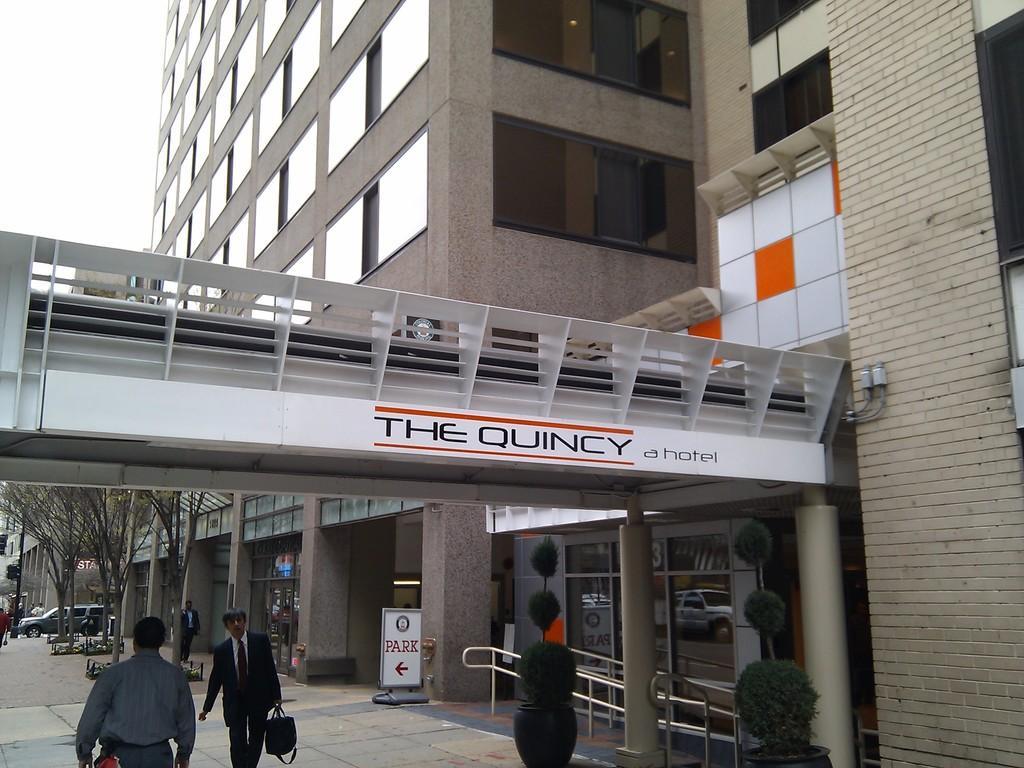In one or two sentences, can you explain what this image depicts? In the picture we can see these people are walking on the road. Here we can see flower pots, a board, railing, pillars, tower building, vehicles moving on the road, we can see trees, traffic signal poles and the sky in the background. 